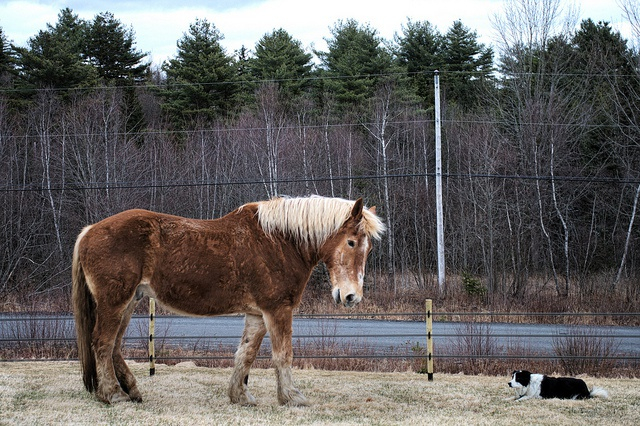Describe the objects in this image and their specific colors. I can see horse in lightblue, maroon, black, brown, and gray tones and dog in lightblue, black, darkgray, lightgray, and gray tones in this image. 